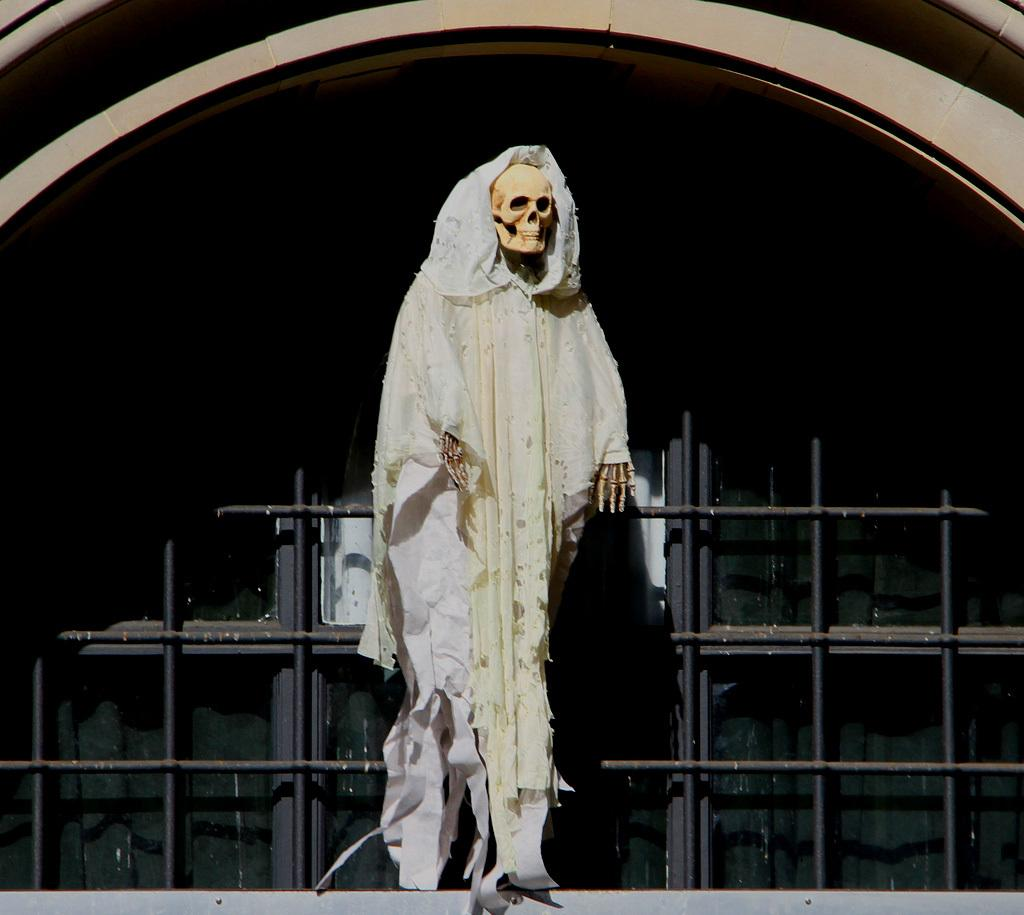What is: What is the main subject of the image? There is a skeleton wearing clothes in the image. What can be seen in the background of the image? There are rods and glass objects visible in the background of the image. What architectural feature is present at the top of the image? There is an arch at the top of the image. What type of tramp is visible in the image? There is no tramp present in the image. What role does the minister play in the image? There is no minister present in the image. 